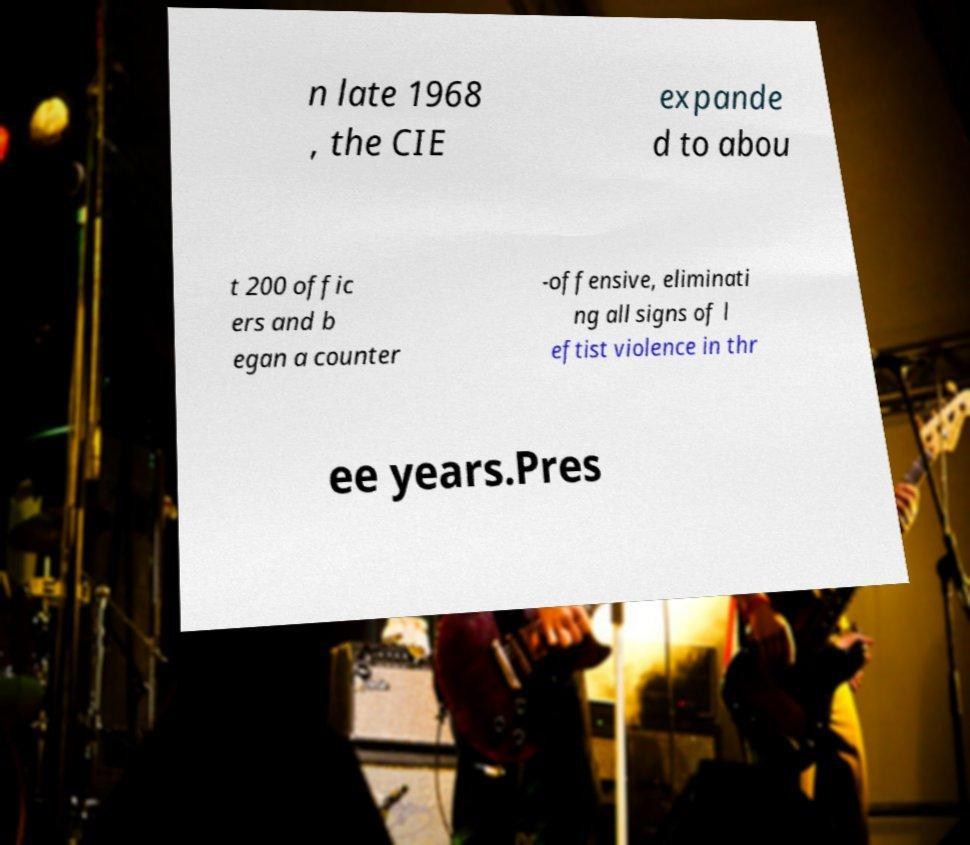What messages or text are displayed in this image? I need them in a readable, typed format. n late 1968 , the CIE expande d to abou t 200 offic ers and b egan a counter -offensive, eliminati ng all signs of l eftist violence in thr ee years.Pres 